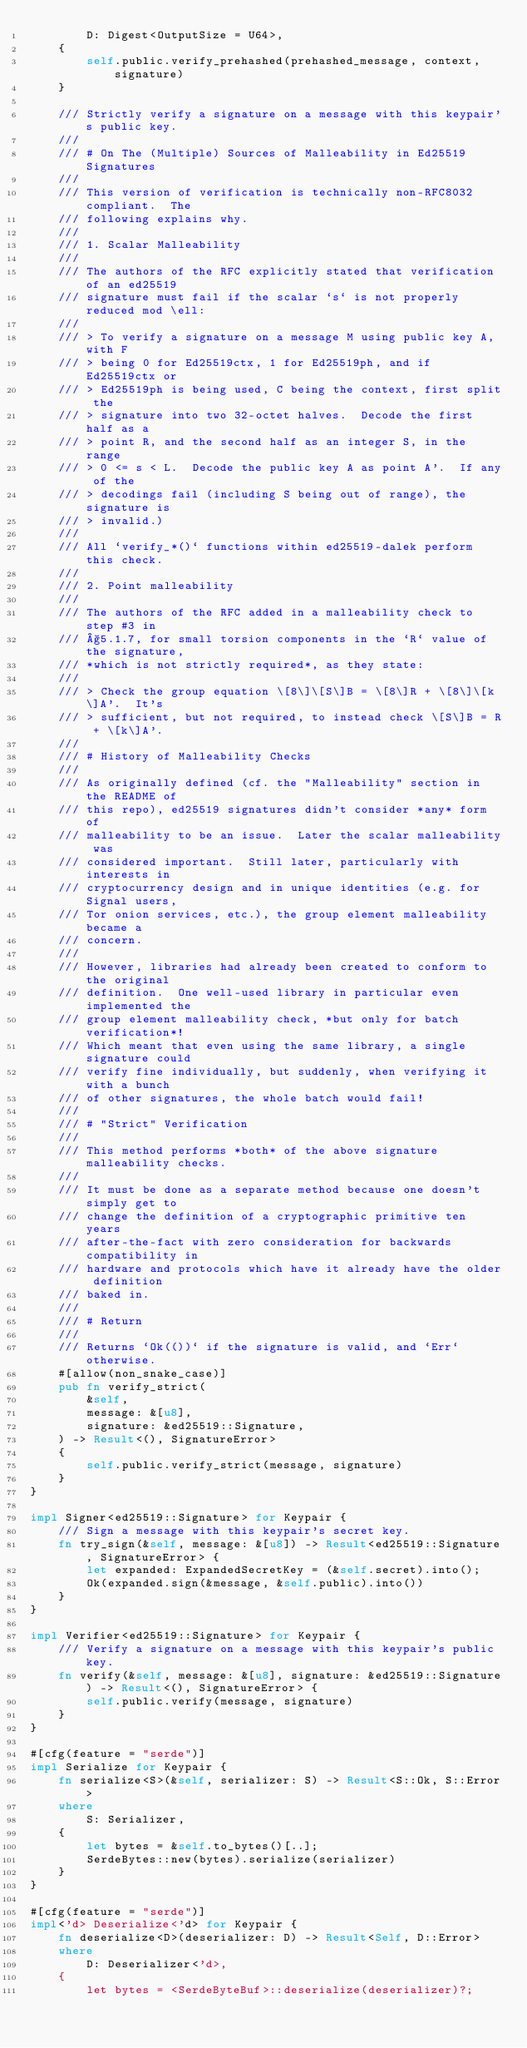Convert code to text. <code><loc_0><loc_0><loc_500><loc_500><_Rust_>        D: Digest<OutputSize = U64>,
    {
        self.public.verify_prehashed(prehashed_message, context, signature)
    }

    /// Strictly verify a signature on a message with this keypair's public key.
    ///
    /// # On The (Multiple) Sources of Malleability in Ed25519 Signatures
    ///
    /// This version of verification is technically non-RFC8032 compliant.  The
    /// following explains why.
    ///
    /// 1. Scalar Malleability
    ///
    /// The authors of the RFC explicitly stated that verification of an ed25519
    /// signature must fail if the scalar `s` is not properly reduced mod \ell:
    ///
    /// > To verify a signature on a message M using public key A, with F
    /// > being 0 for Ed25519ctx, 1 for Ed25519ph, and if Ed25519ctx or
    /// > Ed25519ph is being used, C being the context, first split the
    /// > signature into two 32-octet halves.  Decode the first half as a
    /// > point R, and the second half as an integer S, in the range
    /// > 0 <= s < L.  Decode the public key A as point A'.  If any of the
    /// > decodings fail (including S being out of range), the signature is
    /// > invalid.)
    ///
    /// All `verify_*()` functions within ed25519-dalek perform this check.
    ///
    /// 2. Point malleability
    ///
    /// The authors of the RFC added in a malleability check to step #3 in
    /// §5.1.7, for small torsion components in the `R` value of the signature,
    /// *which is not strictly required*, as they state:
    ///
    /// > Check the group equation \[8\]\[S\]B = \[8\]R + \[8\]\[k\]A'.  It's
    /// > sufficient, but not required, to instead check \[S\]B = R + \[k\]A'.
    ///
    /// # History of Malleability Checks
    ///
    /// As originally defined (cf. the "Malleability" section in the README of
    /// this repo), ed25519 signatures didn't consider *any* form of
    /// malleability to be an issue.  Later the scalar malleability was
    /// considered important.  Still later, particularly with interests in
    /// cryptocurrency design and in unique identities (e.g. for Signal users,
    /// Tor onion services, etc.), the group element malleability became a
    /// concern.
    ///
    /// However, libraries had already been created to conform to the original
    /// definition.  One well-used library in particular even implemented the
    /// group element malleability check, *but only for batch verification*!
    /// Which meant that even using the same library, a single signature could
    /// verify fine individually, but suddenly, when verifying it with a bunch
    /// of other signatures, the whole batch would fail!
    ///
    /// # "Strict" Verification
    ///
    /// This method performs *both* of the above signature malleability checks.
    ///
    /// It must be done as a separate method because one doesn't simply get to
    /// change the definition of a cryptographic primitive ten years
    /// after-the-fact with zero consideration for backwards compatibility in
    /// hardware and protocols which have it already have the older definition
    /// baked in.
    ///
    /// # Return
    ///
    /// Returns `Ok(())` if the signature is valid, and `Err` otherwise.
    #[allow(non_snake_case)]
    pub fn verify_strict(
        &self,
        message: &[u8],
        signature: &ed25519::Signature,
    ) -> Result<(), SignatureError>
    {
        self.public.verify_strict(message, signature)
    }
}

impl Signer<ed25519::Signature> for Keypair {
    /// Sign a message with this keypair's secret key.
    fn try_sign(&self, message: &[u8]) -> Result<ed25519::Signature, SignatureError> {
        let expanded: ExpandedSecretKey = (&self.secret).into();
        Ok(expanded.sign(&message, &self.public).into())
    }
}

impl Verifier<ed25519::Signature> for Keypair {
    /// Verify a signature on a message with this keypair's public key.
    fn verify(&self, message: &[u8], signature: &ed25519::Signature) -> Result<(), SignatureError> {
        self.public.verify(message, signature)
    }
}

#[cfg(feature = "serde")]
impl Serialize for Keypair {
    fn serialize<S>(&self, serializer: S) -> Result<S::Ok, S::Error>
    where
        S: Serializer,
    {
        let bytes = &self.to_bytes()[..];
        SerdeBytes::new(bytes).serialize(serializer)
    }
}

#[cfg(feature = "serde")]
impl<'d> Deserialize<'d> for Keypair {
    fn deserialize<D>(deserializer: D) -> Result<Self, D::Error>
    where
        D: Deserializer<'d>,
    {
        let bytes = <SerdeByteBuf>::deserialize(deserializer)?;</code> 